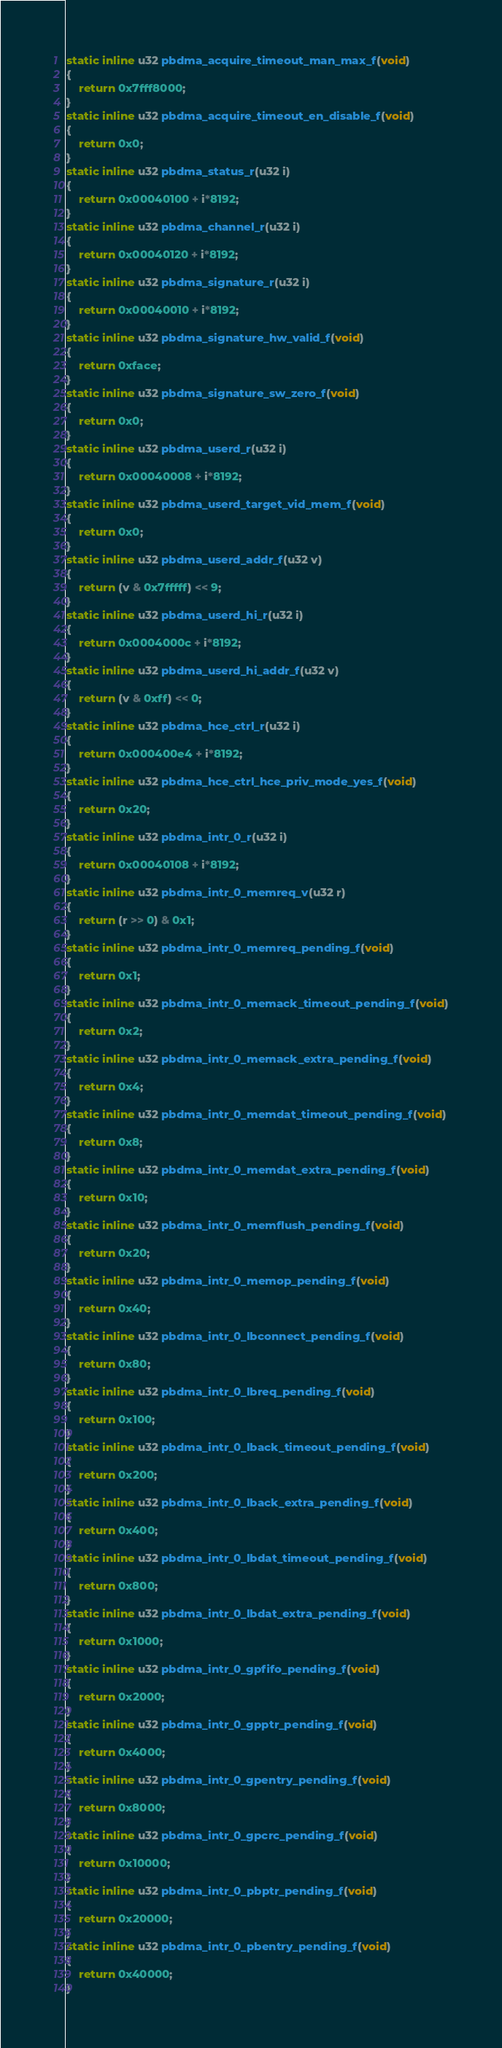<code> <loc_0><loc_0><loc_500><loc_500><_C_>static inline u32 pbdma_acquire_timeout_man_max_f(void)
{
	return 0x7fff8000;
}
static inline u32 pbdma_acquire_timeout_en_disable_f(void)
{
	return 0x0;
}
static inline u32 pbdma_status_r(u32 i)
{
	return 0x00040100 + i*8192;
}
static inline u32 pbdma_channel_r(u32 i)
{
	return 0x00040120 + i*8192;
}
static inline u32 pbdma_signature_r(u32 i)
{
	return 0x00040010 + i*8192;
}
static inline u32 pbdma_signature_hw_valid_f(void)
{
	return 0xface;
}
static inline u32 pbdma_signature_sw_zero_f(void)
{
	return 0x0;
}
static inline u32 pbdma_userd_r(u32 i)
{
	return 0x00040008 + i*8192;
}
static inline u32 pbdma_userd_target_vid_mem_f(void)
{
	return 0x0;
}
static inline u32 pbdma_userd_addr_f(u32 v)
{
	return (v & 0x7fffff) << 9;
}
static inline u32 pbdma_userd_hi_r(u32 i)
{
	return 0x0004000c + i*8192;
}
static inline u32 pbdma_userd_hi_addr_f(u32 v)
{
	return (v & 0xff) << 0;
}
static inline u32 pbdma_hce_ctrl_r(u32 i)
{
	return 0x000400e4 + i*8192;
}
static inline u32 pbdma_hce_ctrl_hce_priv_mode_yes_f(void)
{
	return 0x20;
}
static inline u32 pbdma_intr_0_r(u32 i)
{
	return 0x00040108 + i*8192;
}
static inline u32 pbdma_intr_0_memreq_v(u32 r)
{
	return (r >> 0) & 0x1;
}
static inline u32 pbdma_intr_0_memreq_pending_f(void)
{
	return 0x1;
}
static inline u32 pbdma_intr_0_memack_timeout_pending_f(void)
{
	return 0x2;
}
static inline u32 pbdma_intr_0_memack_extra_pending_f(void)
{
	return 0x4;
}
static inline u32 pbdma_intr_0_memdat_timeout_pending_f(void)
{
	return 0x8;
}
static inline u32 pbdma_intr_0_memdat_extra_pending_f(void)
{
	return 0x10;
}
static inline u32 pbdma_intr_0_memflush_pending_f(void)
{
	return 0x20;
}
static inline u32 pbdma_intr_0_memop_pending_f(void)
{
	return 0x40;
}
static inline u32 pbdma_intr_0_lbconnect_pending_f(void)
{
	return 0x80;
}
static inline u32 pbdma_intr_0_lbreq_pending_f(void)
{
	return 0x100;
}
static inline u32 pbdma_intr_0_lback_timeout_pending_f(void)
{
	return 0x200;
}
static inline u32 pbdma_intr_0_lback_extra_pending_f(void)
{
	return 0x400;
}
static inline u32 pbdma_intr_0_lbdat_timeout_pending_f(void)
{
	return 0x800;
}
static inline u32 pbdma_intr_0_lbdat_extra_pending_f(void)
{
	return 0x1000;
}
static inline u32 pbdma_intr_0_gpfifo_pending_f(void)
{
	return 0x2000;
}
static inline u32 pbdma_intr_0_gpptr_pending_f(void)
{
	return 0x4000;
}
static inline u32 pbdma_intr_0_gpentry_pending_f(void)
{
	return 0x8000;
}
static inline u32 pbdma_intr_0_gpcrc_pending_f(void)
{
	return 0x10000;
}
static inline u32 pbdma_intr_0_pbptr_pending_f(void)
{
	return 0x20000;
}
static inline u32 pbdma_intr_0_pbentry_pending_f(void)
{
	return 0x40000;
}</code> 